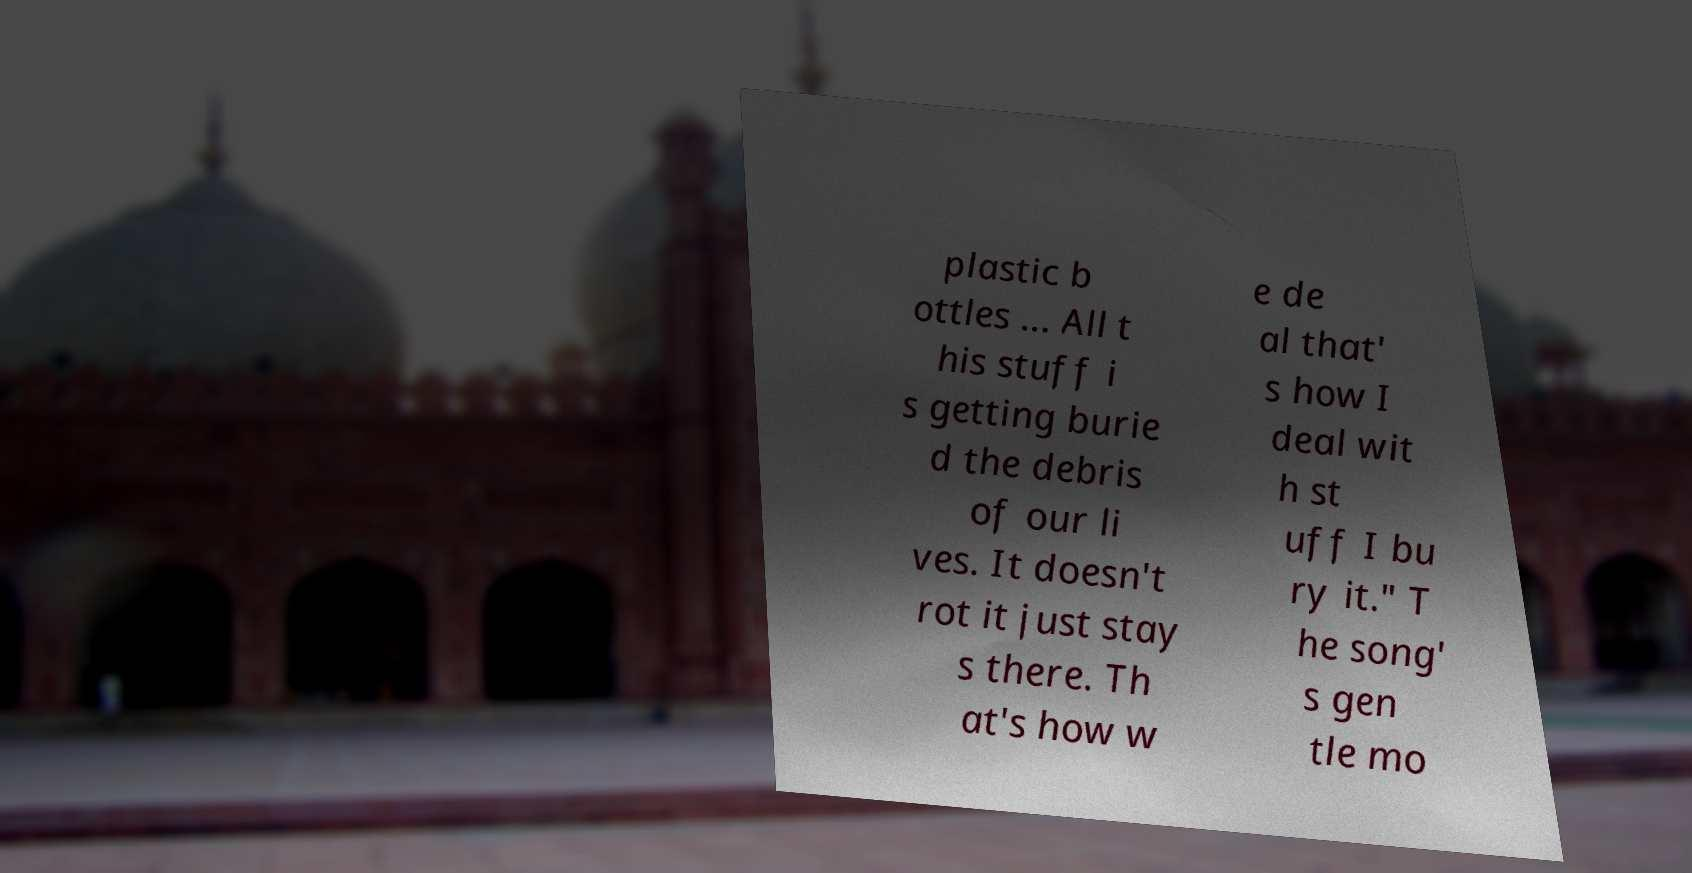Please identify and transcribe the text found in this image. plastic b ottles ... All t his stuff i s getting burie d the debris of our li ves. It doesn't rot it just stay s there. Th at's how w e de al that' s how I deal wit h st uff I bu ry it." T he song' s gen tle mo 